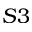Convert formula to latex. <formula><loc_0><loc_0><loc_500><loc_500>S 3</formula> 